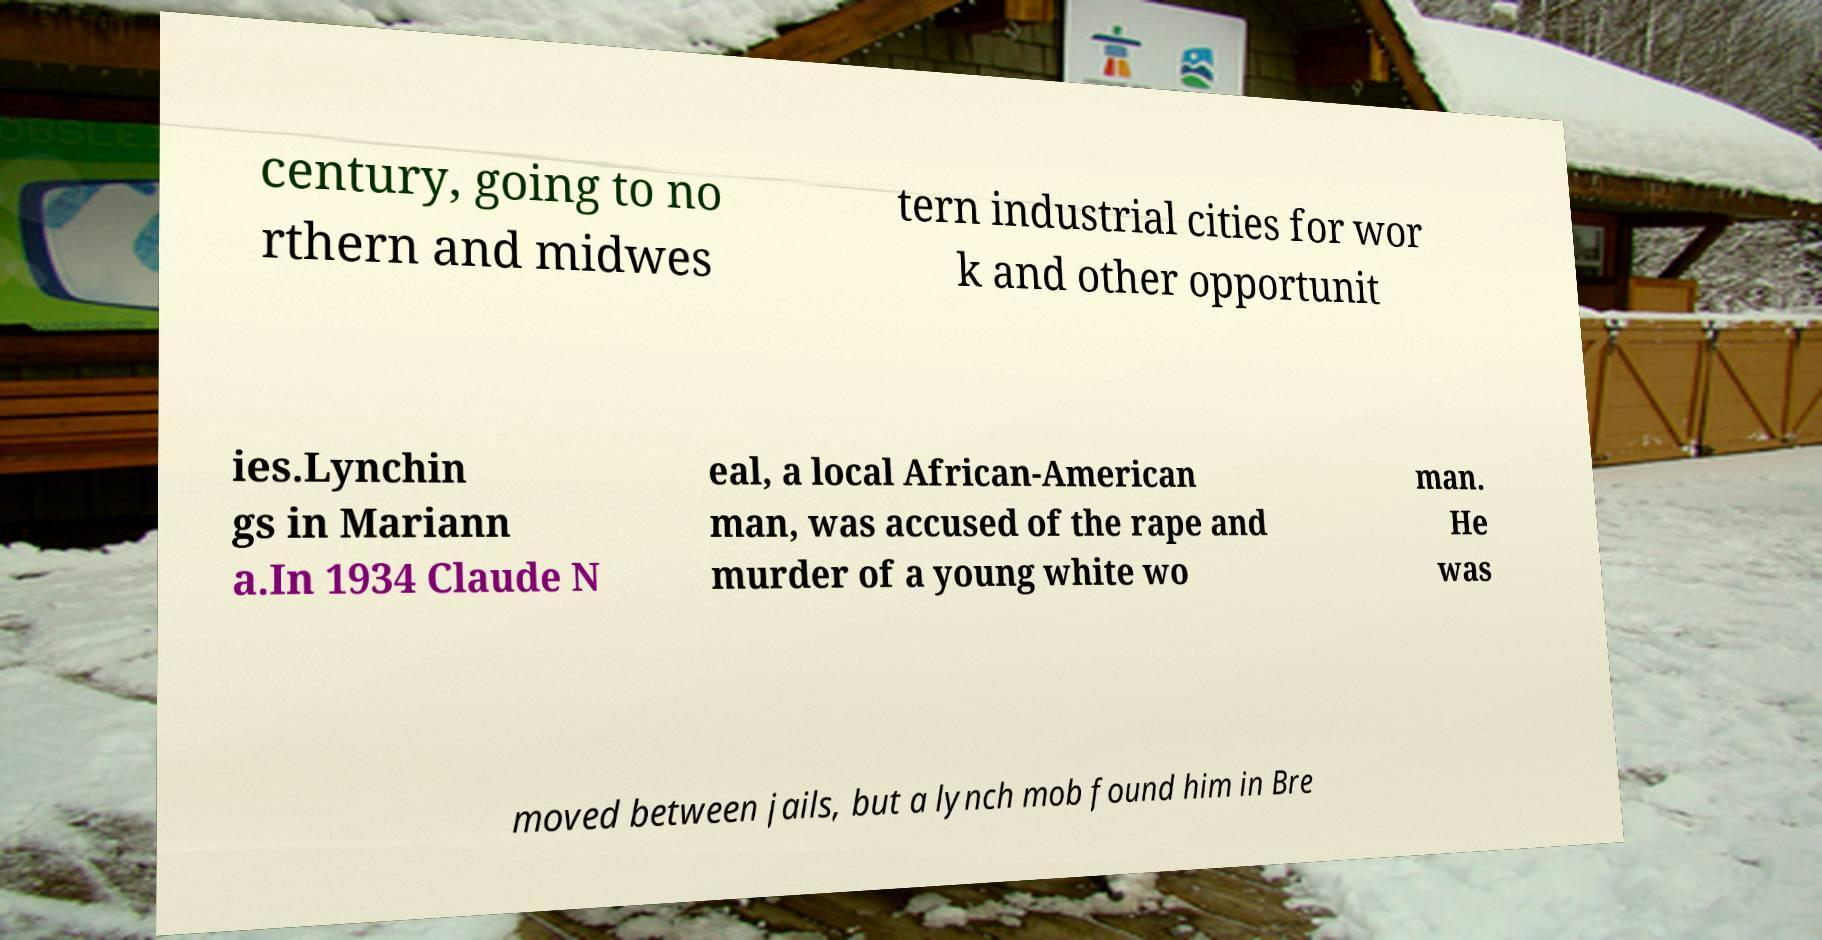Could you assist in decoding the text presented in this image and type it out clearly? century, going to no rthern and midwes tern industrial cities for wor k and other opportunit ies.Lynchin gs in Mariann a.In 1934 Claude N eal, a local African-American man, was accused of the rape and murder of a young white wo man. He was moved between jails, but a lynch mob found him in Bre 